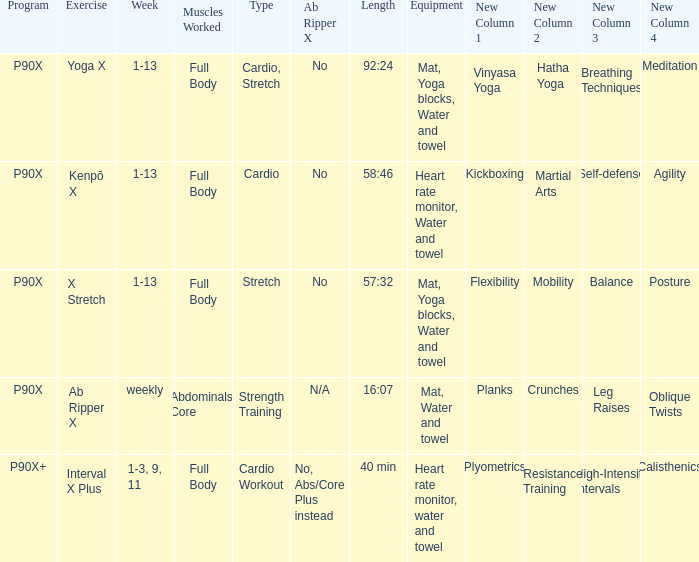In the context of the x stretch exercise, what can be understood as the ab ripper x? No. 